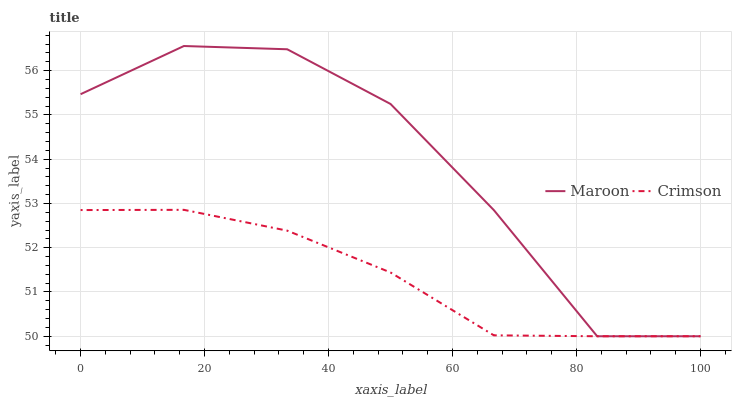Does Crimson have the minimum area under the curve?
Answer yes or no. Yes. Does Maroon have the maximum area under the curve?
Answer yes or no. Yes. Does Maroon have the minimum area under the curve?
Answer yes or no. No. Is Crimson the smoothest?
Answer yes or no. Yes. Is Maroon the roughest?
Answer yes or no. Yes. Is Maroon the smoothest?
Answer yes or no. No. Does Crimson have the lowest value?
Answer yes or no. Yes. Does Maroon have the highest value?
Answer yes or no. Yes. Does Maroon intersect Crimson?
Answer yes or no. Yes. Is Maroon less than Crimson?
Answer yes or no. No. Is Maroon greater than Crimson?
Answer yes or no. No. 